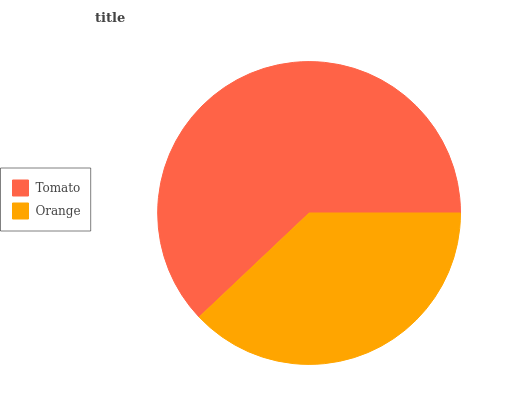Is Orange the minimum?
Answer yes or no. Yes. Is Tomato the maximum?
Answer yes or no. Yes. Is Orange the maximum?
Answer yes or no. No. Is Tomato greater than Orange?
Answer yes or no. Yes. Is Orange less than Tomato?
Answer yes or no. Yes. Is Orange greater than Tomato?
Answer yes or no. No. Is Tomato less than Orange?
Answer yes or no. No. Is Tomato the high median?
Answer yes or no. Yes. Is Orange the low median?
Answer yes or no. Yes. Is Orange the high median?
Answer yes or no. No. Is Tomato the low median?
Answer yes or no. No. 